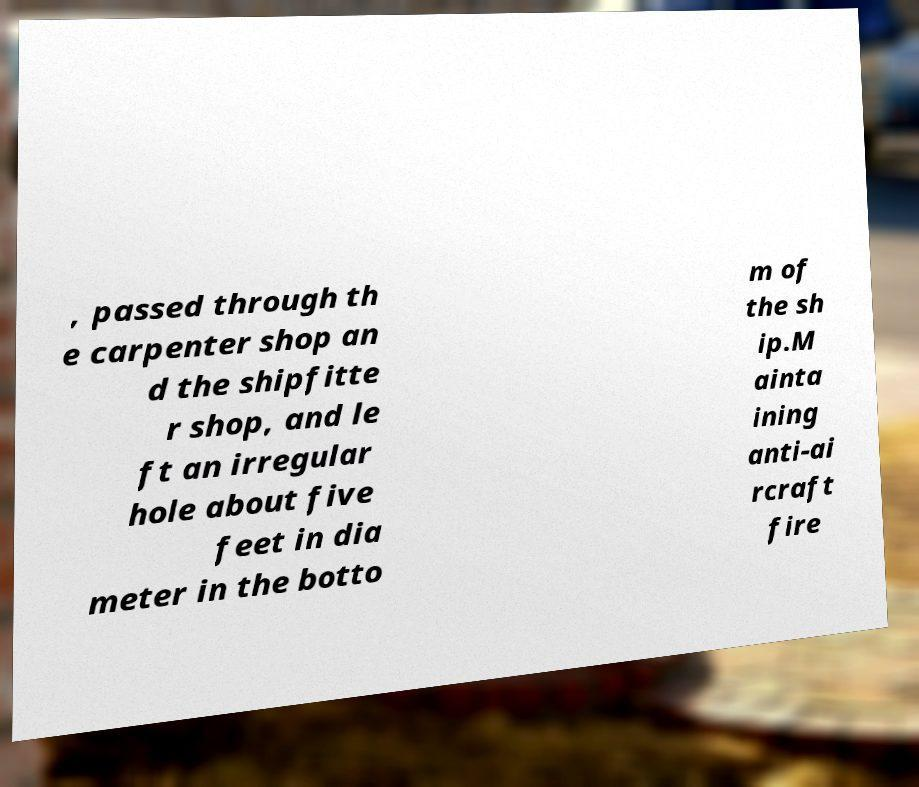I need the written content from this picture converted into text. Can you do that? , passed through th e carpenter shop an d the shipfitte r shop, and le ft an irregular hole about five feet in dia meter in the botto m of the sh ip.M ainta ining anti-ai rcraft fire 